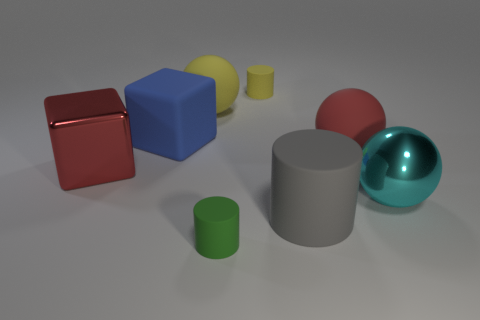Subtract all small matte cylinders. How many cylinders are left? 1 Subtract 1 balls. How many balls are left? 2 Add 1 large brown rubber balls. How many objects exist? 9 Add 4 big cyan objects. How many big cyan objects exist? 5 Subtract 0 green spheres. How many objects are left? 8 Subtract all spheres. How many objects are left? 5 Subtract all green cubes. Subtract all green cylinders. How many cubes are left? 2 Subtract all small rubber objects. Subtract all gray cylinders. How many objects are left? 5 Add 4 green cylinders. How many green cylinders are left? 5 